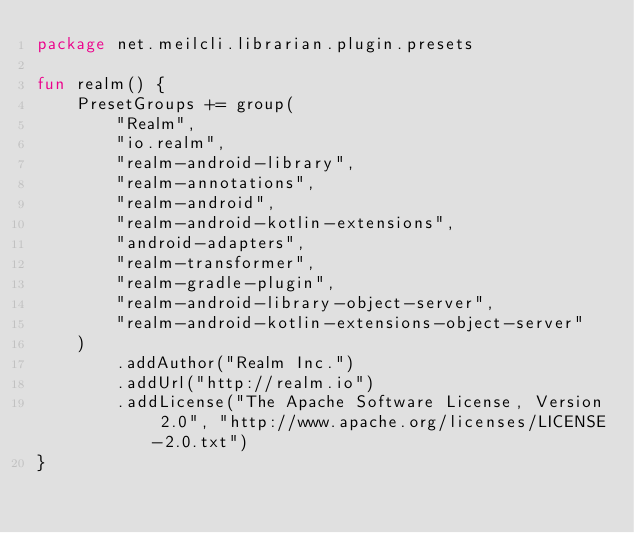<code> <loc_0><loc_0><loc_500><loc_500><_Kotlin_>package net.meilcli.librarian.plugin.presets

fun realm() {
    PresetGroups += group(
        "Realm",
        "io.realm",
        "realm-android-library",
        "realm-annotations",
        "realm-android",
        "realm-android-kotlin-extensions",
        "android-adapters",
        "realm-transformer",
        "realm-gradle-plugin",
        "realm-android-library-object-server",
        "realm-android-kotlin-extensions-object-server"
    )
        .addAuthor("Realm Inc.")
        .addUrl("http://realm.io")
        .addLicense("The Apache Software License, Version 2.0", "http://www.apache.org/licenses/LICENSE-2.0.txt")
}</code> 